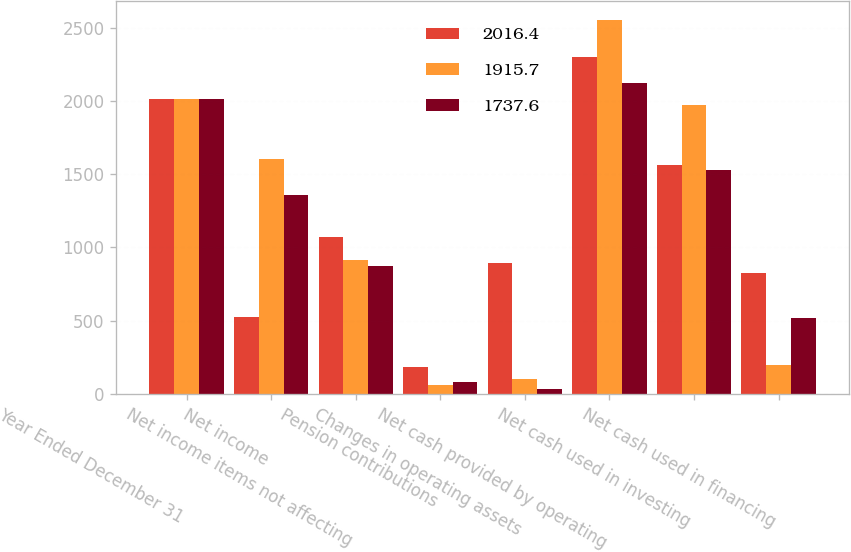Convert chart. <chart><loc_0><loc_0><loc_500><loc_500><stacked_bar_chart><ecel><fcel>Year Ended December 31<fcel>Net income<fcel>Net income items not affecting<fcel>Pension contributions<fcel>Changes in operating assets<fcel>Net cash provided by operating<fcel>Net cash used in investing<fcel>Net cash used in financing<nl><fcel>2016.4<fcel>2016<fcel>521.7<fcel>1072.7<fcel>185.7<fcel>892.1<fcel>2300.8<fcel>1564.3<fcel>823.5<nl><fcel>1915.7<fcel>2015<fcel>1604<fcel>910.9<fcel>62.9<fcel>104<fcel>2556<fcel>1974.9<fcel>196.5<nl><fcel>1737.6<fcel>2014<fcel>1358.8<fcel>875.5<fcel>81.1<fcel>29.6<fcel>2123.6<fcel>1531.9<fcel>520.5<nl></chart> 